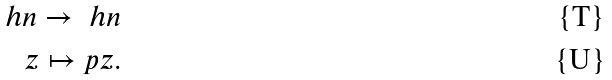<formula> <loc_0><loc_0><loc_500><loc_500>\ h n \rightarrow \ h n \\ z \mapsto p z .</formula> 